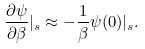<formula> <loc_0><loc_0><loc_500><loc_500>\frac { \partial \psi } { \partial \beta } | _ { s } \approx - \frac { 1 } { \beta } \psi ( 0 ) | _ { s } .</formula> 